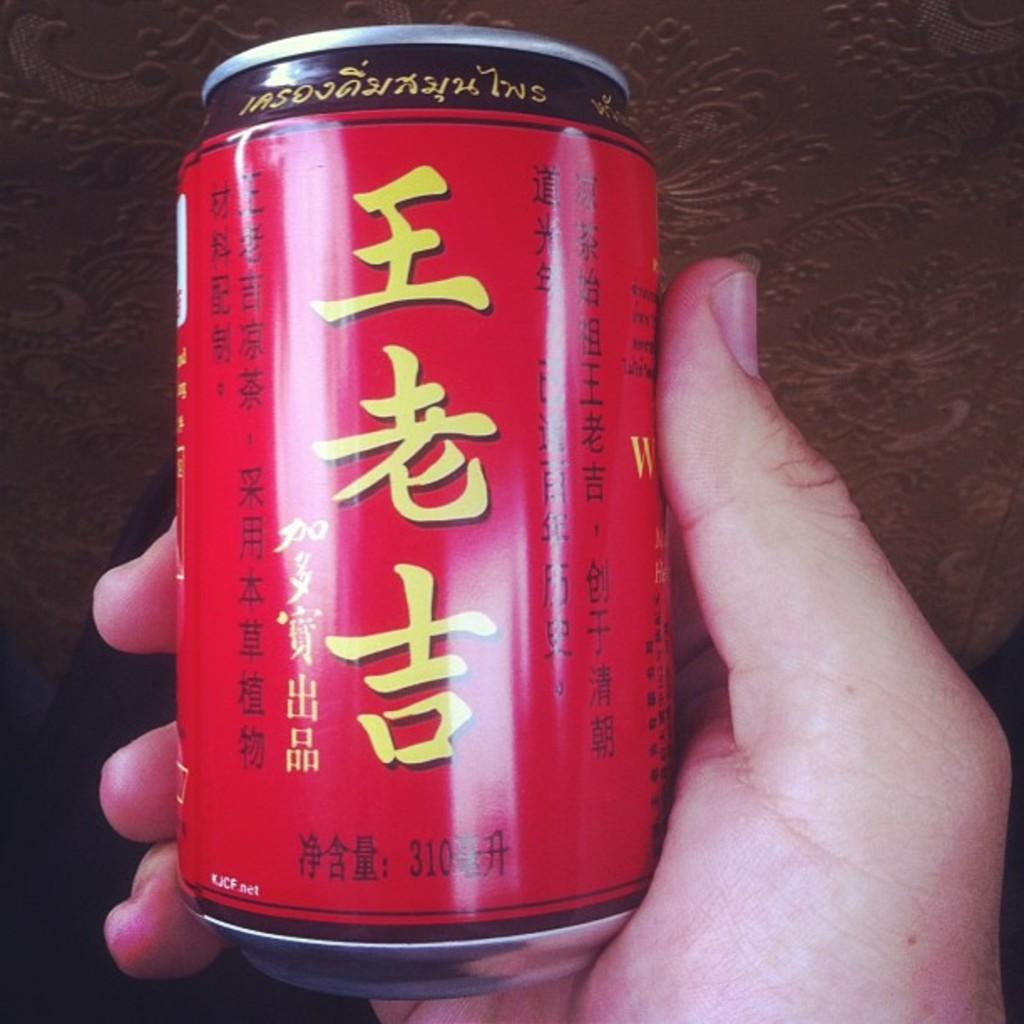What is the volume of the drink?
Offer a very short reply. 310. 